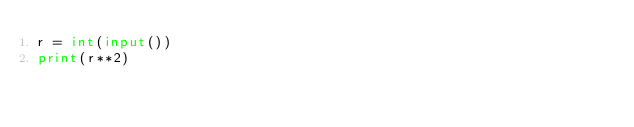<code> <loc_0><loc_0><loc_500><loc_500><_Python_>r = int(input())
print(r**2)</code> 